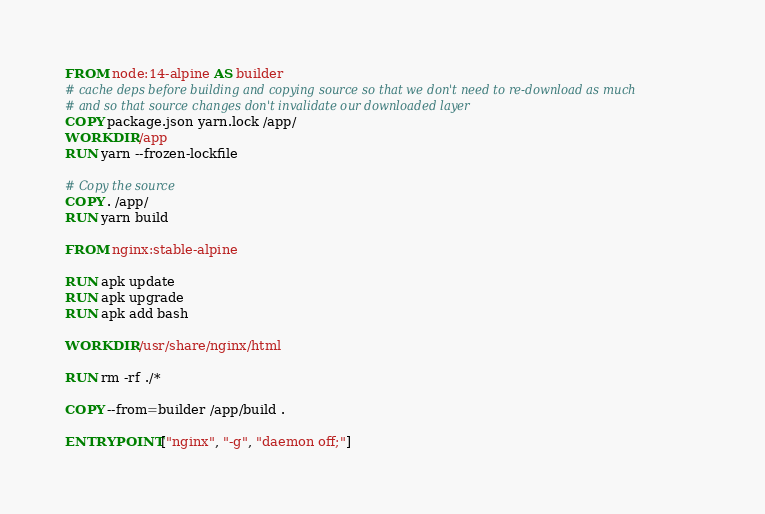Convert code to text. <code><loc_0><loc_0><loc_500><loc_500><_Dockerfile_>FROM node:14-alpine AS builder
# cache deps before building and copying source so that we don't need to re-download as much
# and so that source changes don't invalidate our downloaded layer
COPY package.json yarn.lock /app/
WORKDIR /app
RUN yarn --frozen-lockfile

# Copy the source
COPY . /app/
RUN yarn build

FROM nginx:stable-alpine

RUN apk update
RUN apk upgrade
RUN apk add bash

WORKDIR /usr/share/nginx/html

RUN rm -rf ./*

COPY --from=builder /app/build .

ENTRYPOINT ["nginx", "-g", "daemon off;"]</code> 